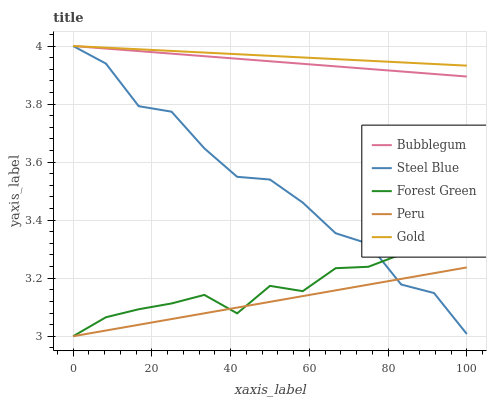Does Peru have the minimum area under the curve?
Answer yes or no. Yes. Does Gold have the maximum area under the curve?
Answer yes or no. Yes. Does Forest Green have the minimum area under the curve?
Answer yes or no. No. Does Forest Green have the maximum area under the curve?
Answer yes or no. No. Is Gold the smoothest?
Answer yes or no. Yes. Is Steel Blue the roughest?
Answer yes or no. Yes. Is Forest Green the smoothest?
Answer yes or no. No. Is Forest Green the roughest?
Answer yes or no. No. Does Gold have the lowest value?
Answer yes or no. No. Does Bubblegum have the highest value?
Answer yes or no. Yes. Does Forest Green have the highest value?
Answer yes or no. No. Is Peru less than Bubblegum?
Answer yes or no. Yes. Is Gold greater than Forest Green?
Answer yes or no. Yes. Does Bubblegum intersect Gold?
Answer yes or no. Yes. Is Bubblegum less than Gold?
Answer yes or no. No. Is Bubblegum greater than Gold?
Answer yes or no. No. Does Peru intersect Bubblegum?
Answer yes or no. No. 